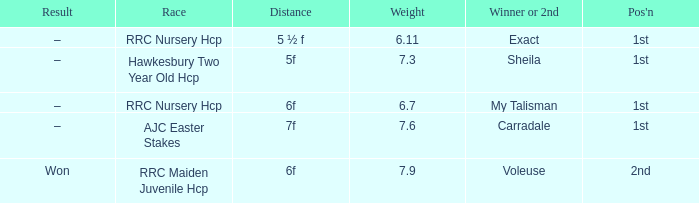What is the maximum weight with a result of –, and a distance of 7f? 7.6. 